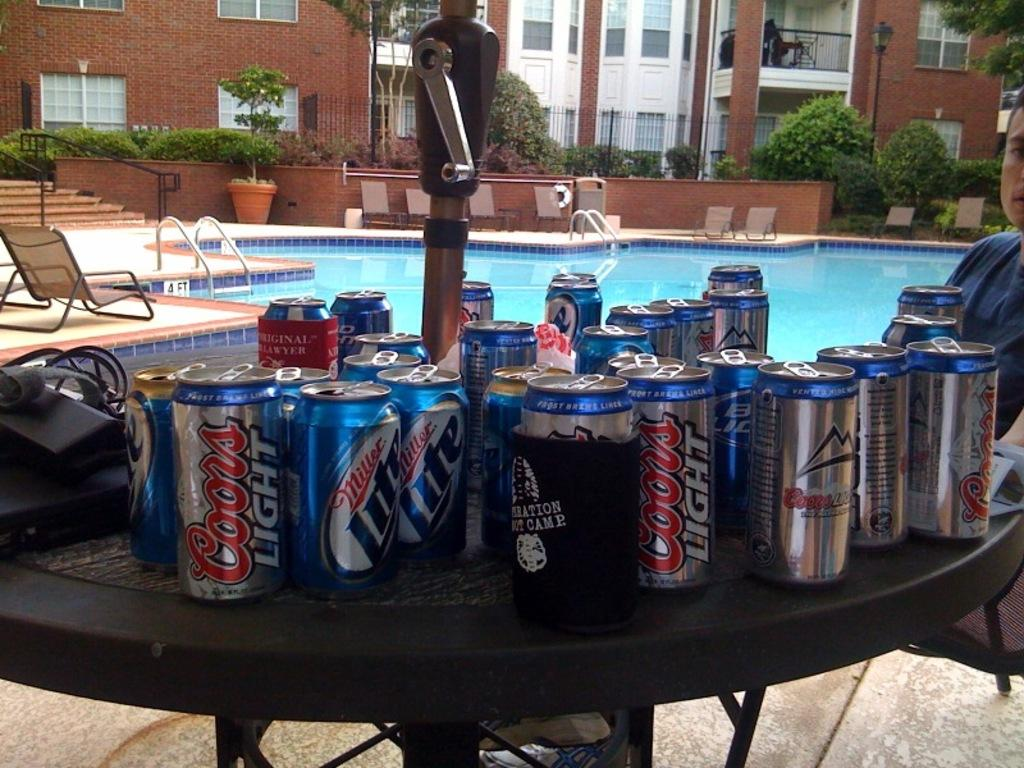<image>
Create a compact narrative representing the image presented. Several beer cans from Miller Lite and Coors Light are sitting on an outdoor table. 